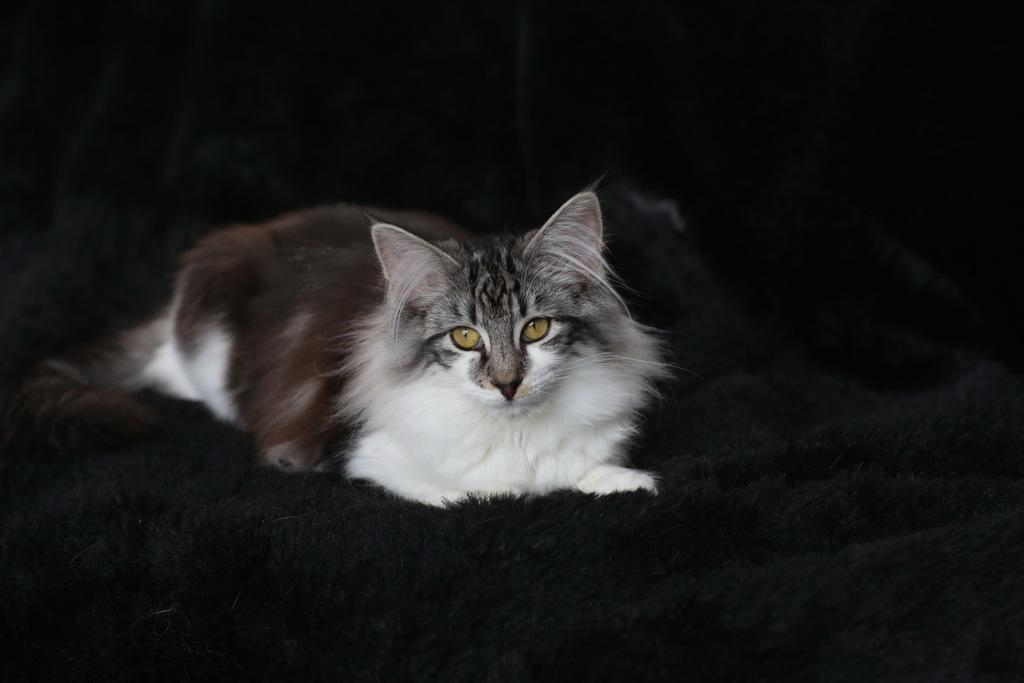What type of animal is in the image? There is a cat in the image. Can you describe the color pattern of the cat? The cat has white and gray colors. What other object is present in the image besides the cat? There is a cloth in the image. What color is the cloth? The cloth is black in color. What letters does the cat spell out with its tail in the image? There are no letters present in the image, and the cat's tail is not spelling out any words. How many teeth can be seen in the image? There are no teeth visible in the image, as it features a cat and a cloth. 